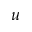<formula> <loc_0><loc_0><loc_500><loc_500>u</formula> 